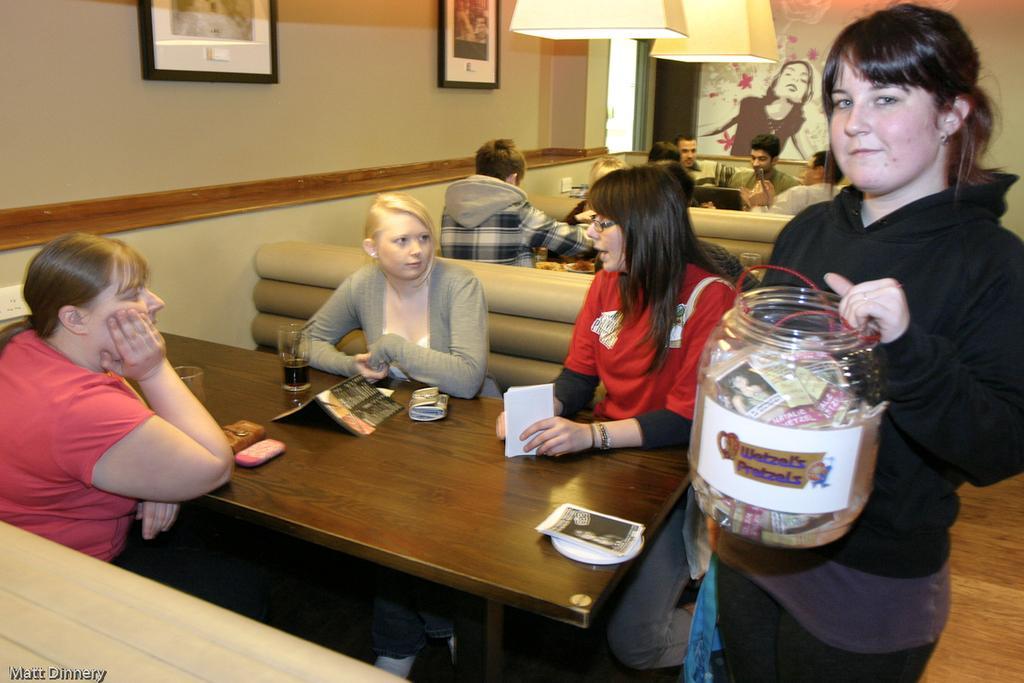In one or two sentences, can you explain what this image depicts? In this image, few peoples are sat on the sofa. We can see so many tables. Few items are placed on it. On right a woman is holding a container that is filled with some papers. On left side, we can see a cream color wall, for photo frames. Lamps on the top of the image. And the wooden floor on the left side. 